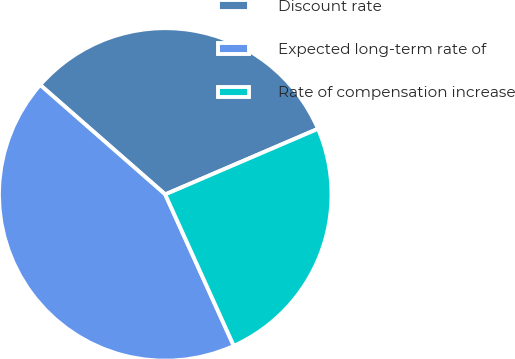Convert chart. <chart><loc_0><loc_0><loc_500><loc_500><pie_chart><fcel>Discount rate<fcel>Expected long-term rate of<fcel>Rate of compensation increase<nl><fcel>32.1%<fcel>43.21%<fcel>24.69%<nl></chart> 